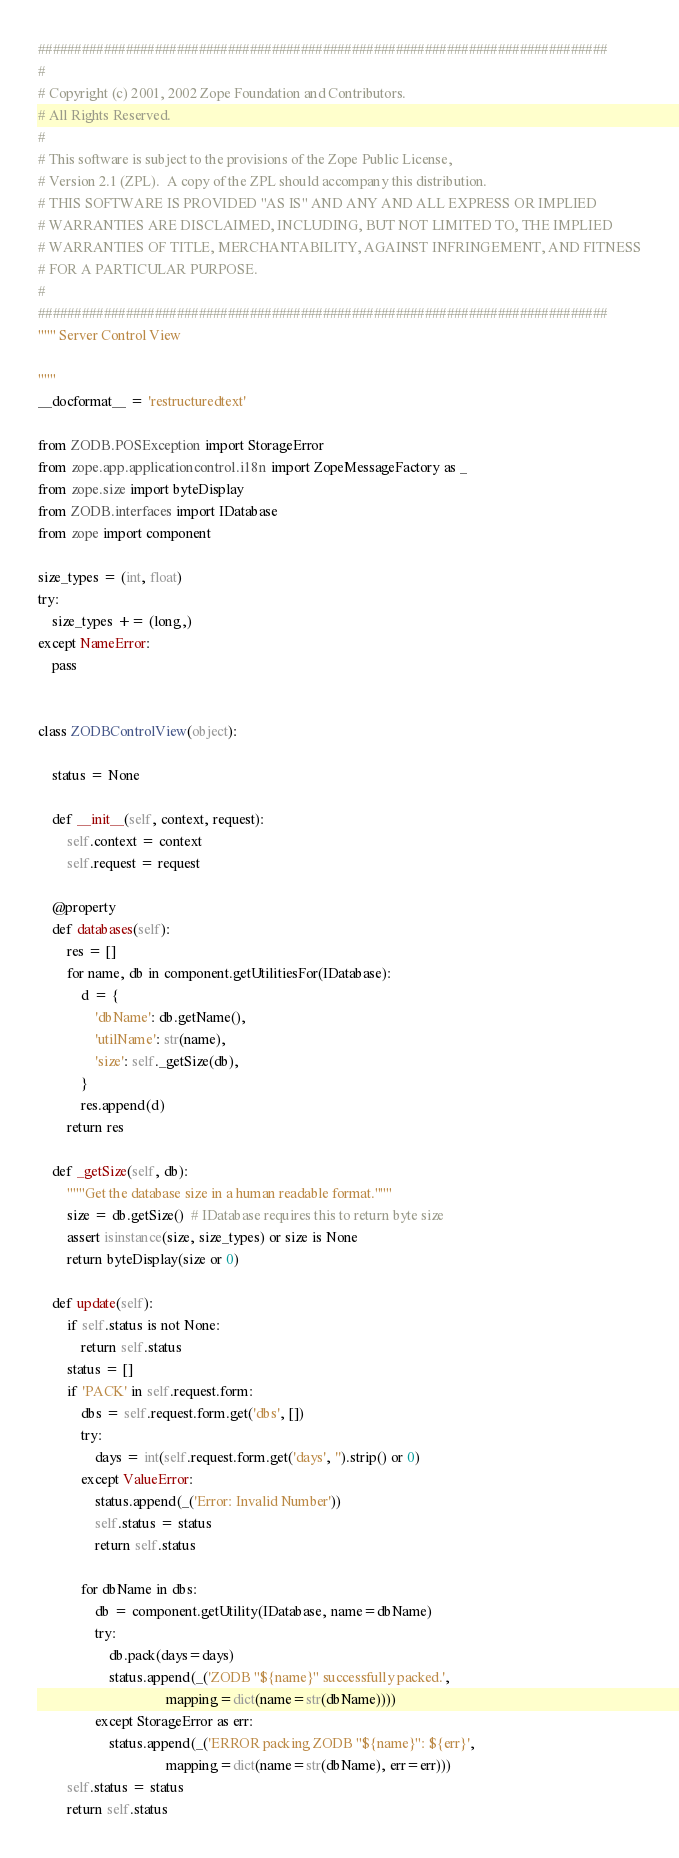Convert code to text. <code><loc_0><loc_0><loc_500><loc_500><_Python_>##############################################################################
#
# Copyright (c) 2001, 2002 Zope Foundation and Contributors.
# All Rights Reserved.
#
# This software is subject to the provisions of the Zope Public License,
# Version 2.1 (ZPL).  A copy of the ZPL should accompany this distribution.
# THIS SOFTWARE IS PROVIDED "AS IS" AND ANY AND ALL EXPRESS OR IMPLIED
# WARRANTIES ARE DISCLAIMED, INCLUDING, BUT NOT LIMITED TO, THE IMPLIED
# WARRANTIES OF TITLE, MERCHANTABILITY, AGAINST INFRINGEMENT, AND FITNESS
# FOR A PARTICULAR PURPOSE.
#
##############################################################################
""" Server Control View

"""
__docformat__ = 'restructuredtext'

from ZODB.POSException import StorageError
from zope.app.applicationcontrol.i18n import ZopeMessageFactory as _
from zope.size import byteDisplay
from ZODB.interfaces import IDatabase
from zope import component

size_types = (int, float)
try:
    size_types += (long,)
except NameError:
    pass


class ZODBControlView(object):

    status = None

    def __init__(self, context, request):
        self.context = context
        self.request = request

    @property
    def databases(self):
        res = []
        for name, db in component.getUtilitiesFor(IDatabase):
            d = {
                'dbName': db.getName(),
                'utilName': str(name),
                'size': self._getSize(db),
            }
            res.append(d)
        return res

    def _getSize(self, db):
        """Get the database size in a human readable format."""
        size = db.getSize()  # IDatabase requires this to return byte size
        assert isinstance(size, size_types) or size is None
        return byteDisplay(size or 0)

    def update(self):
        if self.status is not None:
            return self.status
        status = []
        if 'PACK' in self.request.form:
            dbs = self.request.form.get('dbs', [])
            try:
                days = int(self.request.form.get('days', '').strip() or 0)
            except ValueError:
                status.append(_('Error: Invalid Number'))
                self.status = status
                return self.status

            for dbName in dbs:
                db = component.getUtility(IDatabase, name=dbName)
                try:
                    db.pack(days=days)
                    status.append(_('ZODB "${name}" successfully packed.',
                                    mapping=dict(name=str(dbName))))
                except StorageError as err:
                    status.append(_('ERROR packing ZODB "${name}": ${err}',
                                    mapping=dict(name=str(dbName), err=err)))
        self.status = status
        return self.status
</code> 